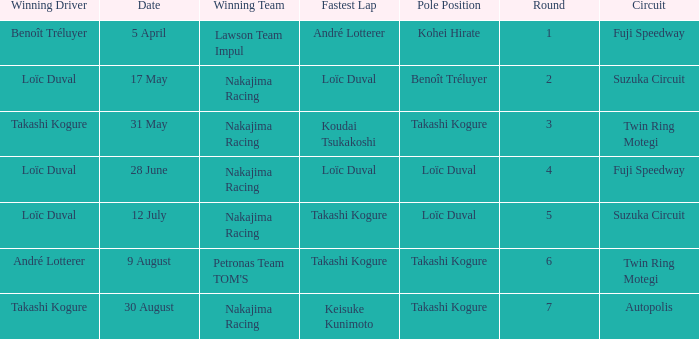Who has the fastest lap where Benoît Tréluyer got the pole position? Loïc Duval. 